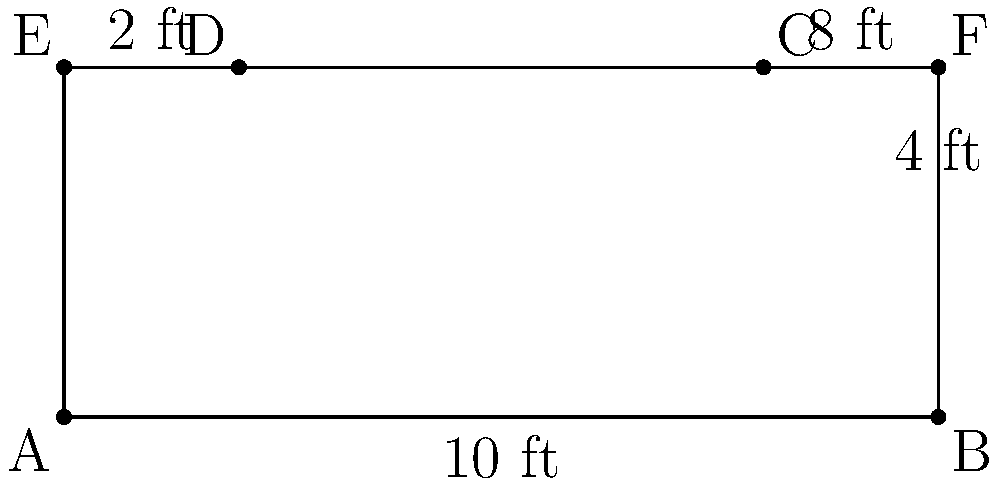A discreet judge's bench has a trapezoidal front panel and a rectangular top. The front panel measures 10 ft at the base and has a height of 4 ft, with the top edge measuring 8 ft. The depth of the bench top is 2 ft. Calculate the total surface area of the bench, including the top, front, and two sides. Let's approach this step-by-step:

1) First, calculate the area of the trapezoidal front panel:
   Area of trapezoid = $\frac{1}{2}(b_1 + b_2)h$
   where $b_1 = 10$ ft, $b_2 = 8$ ft, and $h = 4$ ft
   Area of front = $\frac{1}{2}(10 + 8) \times 4 = 36$ sq ft

2) Calculate the area of the rectangular top:
   Area of top = length $\times$ width
   $= 8 \times 2 = 16$ sq ft

3) Calculate the area of each side panel:
   The side panels are right trapezoids.
   Area of right trapezoid = $\frac{1}{2}(a + b)h$
   where $a = 2$ ft, $b = 4$ ft, and $h = 2$ ft
   Area of one side = $\frac{1}{2}(2 + 4) \times 2 = 6$ sq ft
   Area of both sides = $6 \times 2 = 12$ sq ft

4) Sum up all the areas:
   Total surface area = Front + Top + Both Sides
   $= 36 + 16 + 12 = 64$ sq ft
Answer: 64 sq ft 